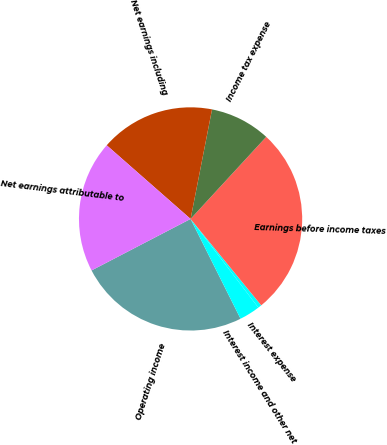Convert chart to OTSL. <chart><loc_0><loc_0><loc_500><loc_500><pie_chart><fcel>Operating income<fcel>Interest income and other net<fcel>Interest expense<fcel>Earnings before income taxes<fcel>Income tax expense<fcel>Net earnings including<fcel>Net earnings attributable to<nl><fcel>24.75%<fcel>3.0%<fcel>0.52%<fcel>27.24%<fcel>8.77%<fcel>16.61%<fcel>19.1%<nl></chart> 